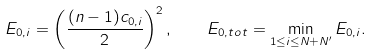Convert formula to latex. <formula><loc_0><loc_0><loc_500><loc_500>E _ { 0 , i } = \left ( \frac { ( n - 1 ) c _ { 0 , i } } { 2 } \right ) ^ { 2 } , \quad E _ { 0 , t o t } = \min _ { 1 \leq i \leq N + N ^ { \prime } } E _ { 0 , i } .</formula> 